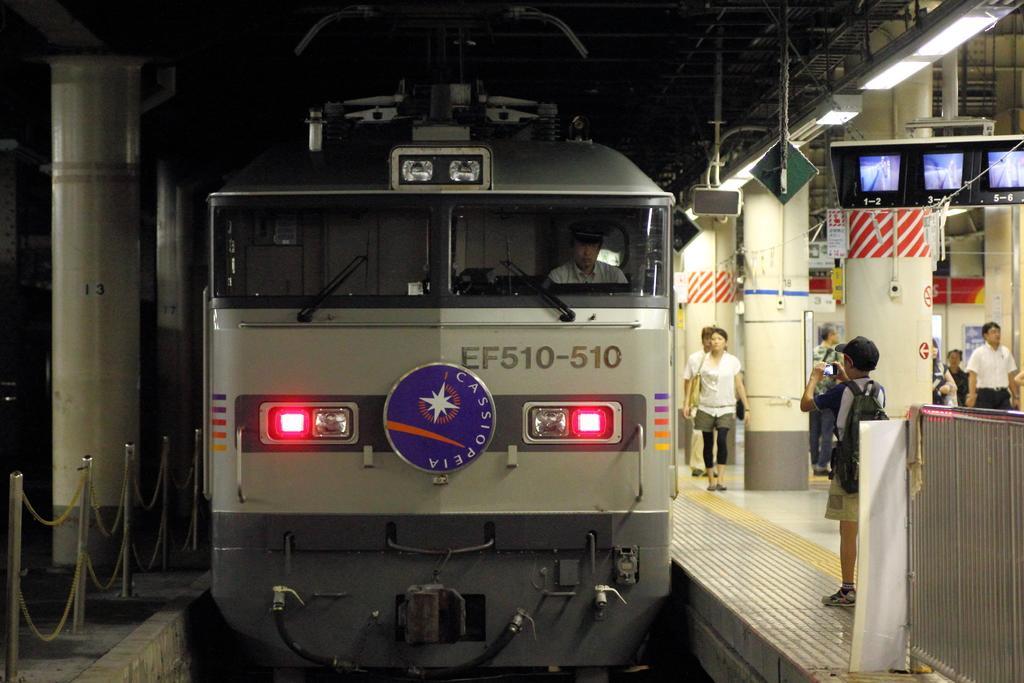Describe this image in one or two sentences. In the picture we can see a train with lights, windshield and a person sitting inside and beside the train we can see a platform and on it we can see some people walking and some are standing and beside them we can see some pillars and to it we can see a TV and on the other side of the train we can see some pillars. 